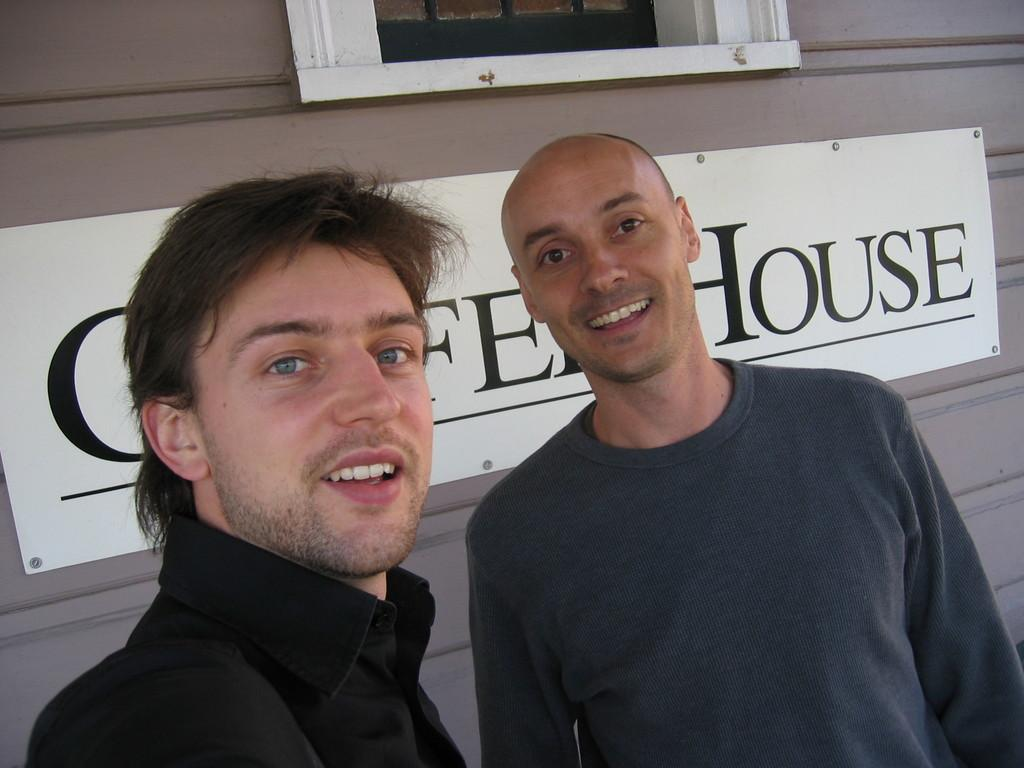How many people are present in the image? There are two men standing in the image. What is the facial expression of the men in the image? The men are smiling. What can be seen on the wall in the image? There is a name board fixed to the wall. What architectural feature is visible in the image? There is a window in the image. What type of scissors can be seen cutting through the fog in the image? There are no scissors or fog present in the image; it features two men standing and smiling. 